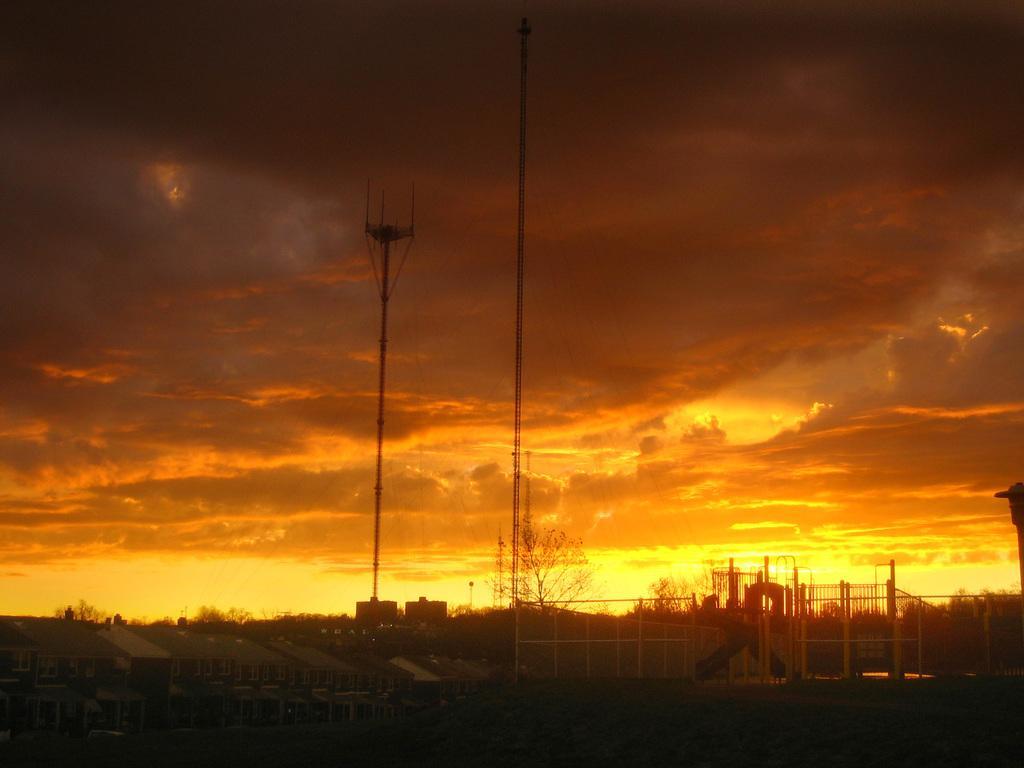Describe this image in one or two sentences. In this image I can see trees, buildings and poles. There are clouds in the sky. 